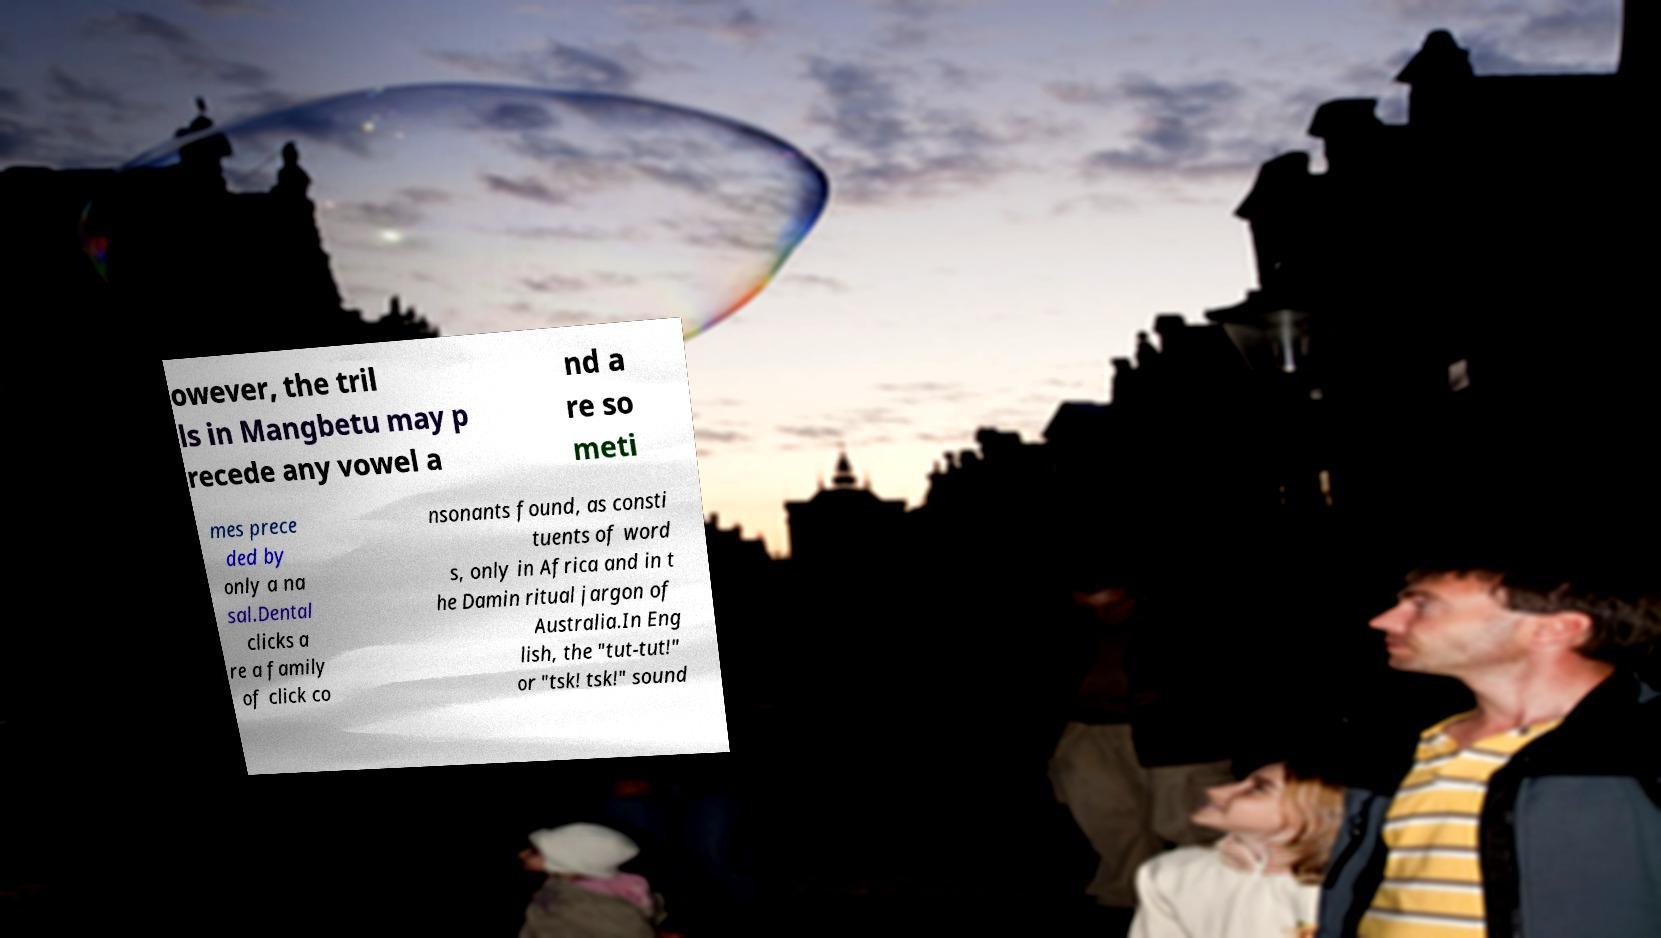There's text embedded in this image that I need extracted. Can you transcribe it verbatim? owever, the tril ls in Mangbetu may p recede any vowel a nd a re so meti mes prece ded by only a na sal.Dental clicks a re a family of click co nsonants found, as consti tuents of word s, only in Africa and in t he Damin ritual jargon of Australia.In Eng lish, the "tut-tut!" or "tsk! tsk!" sound 